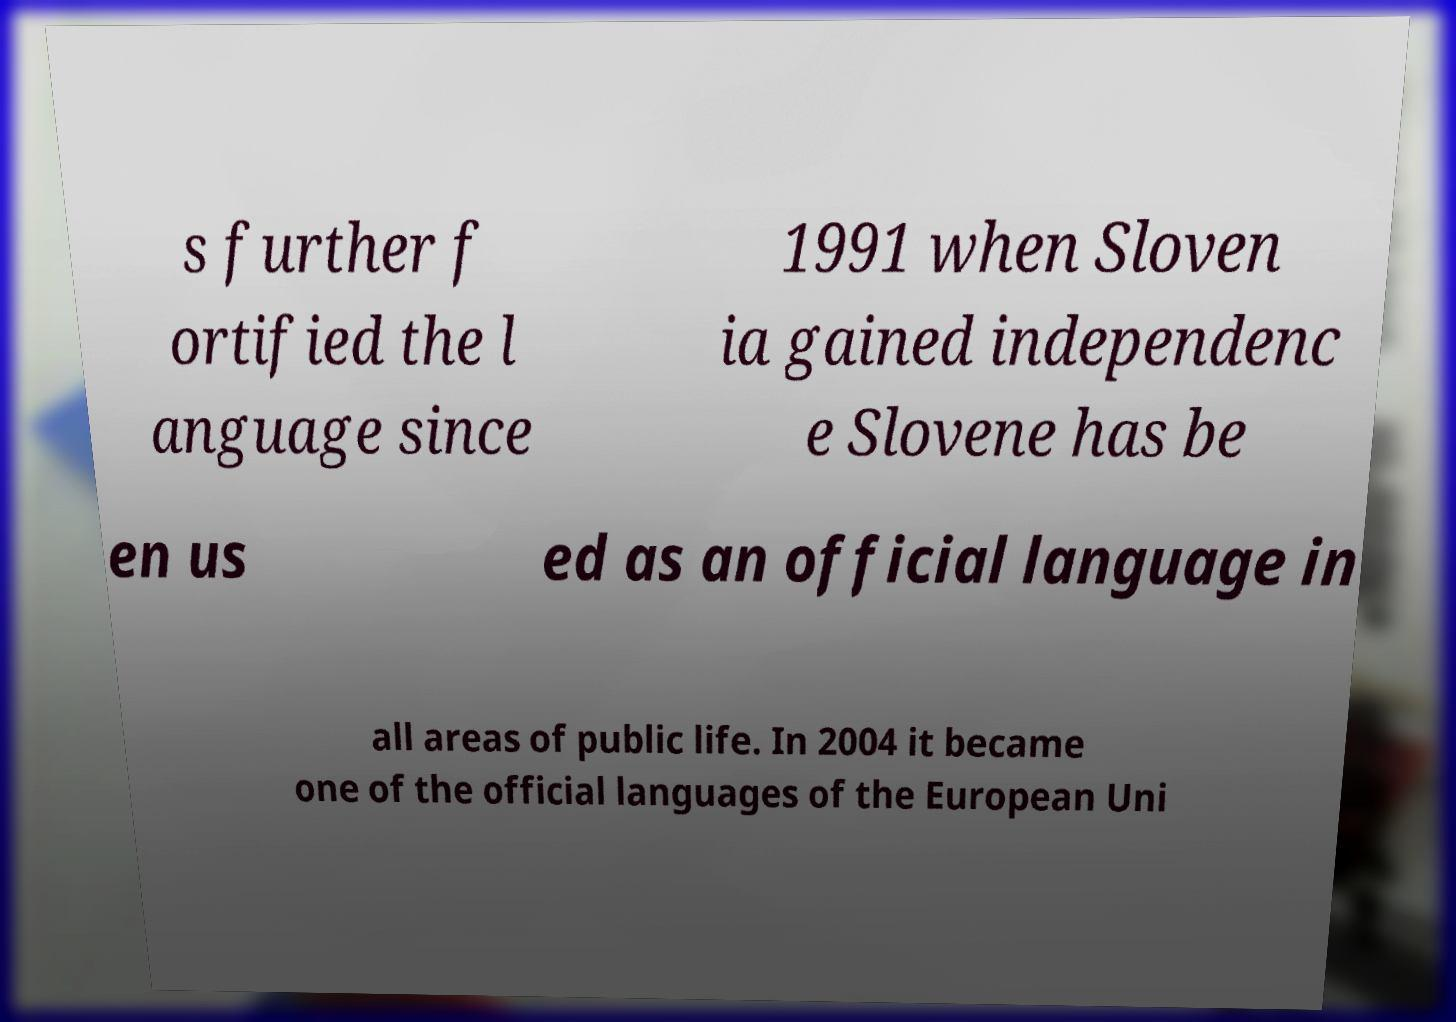Can you read and provide the text displayed in the image?This photo seems to have some interesting text. Can you extract and type it out for me? s further f ortified the l anguage since 1991 when Sloven ia gained independenc e Slovene has be en us ed as an official language in all areas of public life. In 2004 it became one of the official languages of the European Uni 